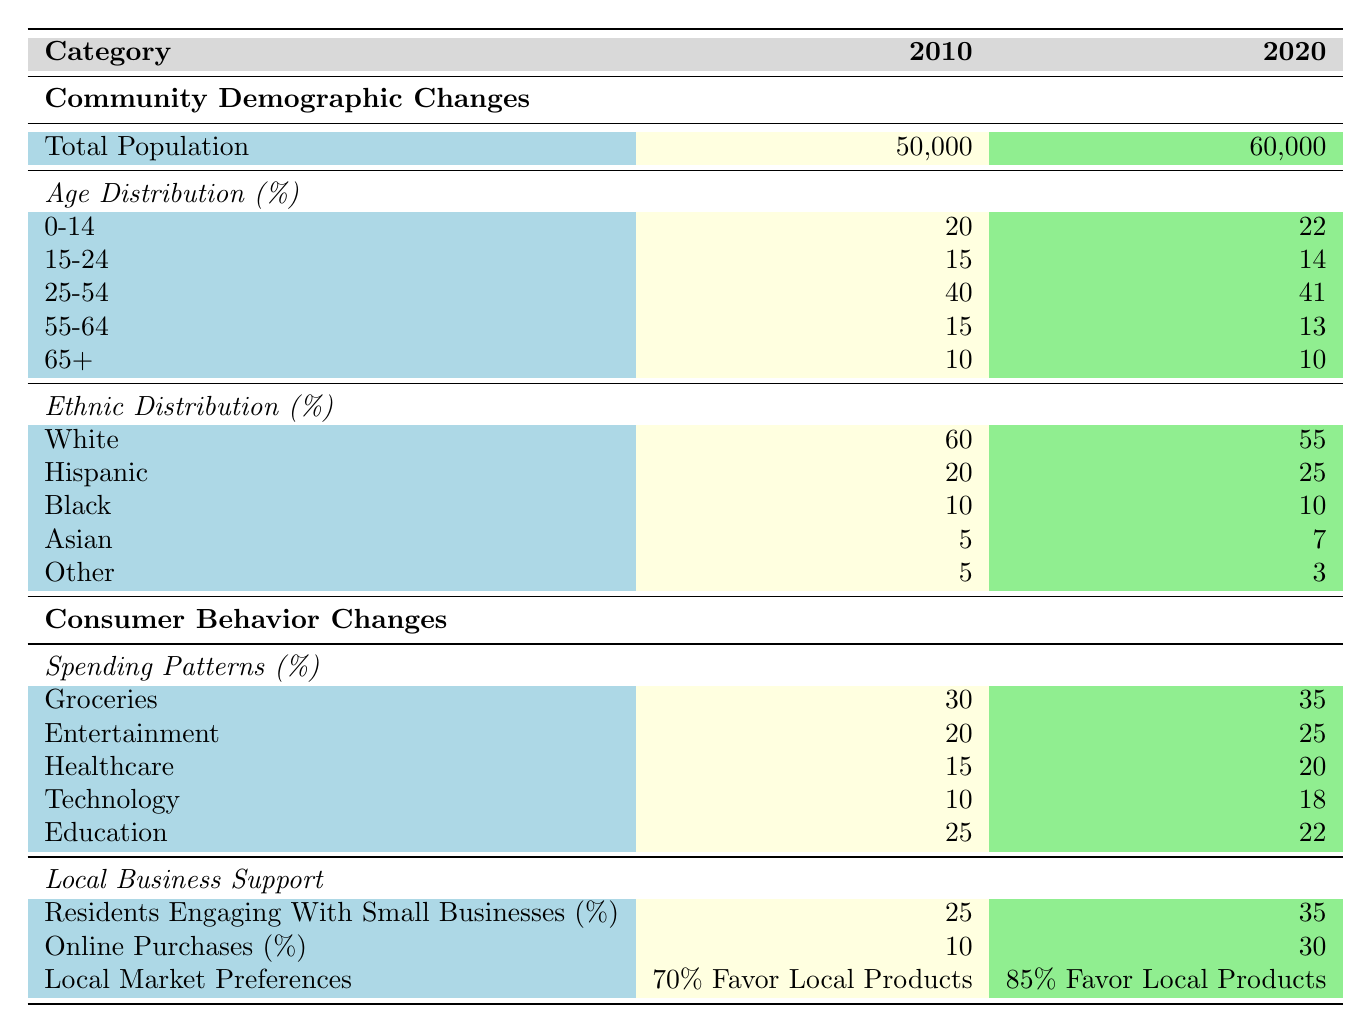What was the total population in 2010? Referring to the table, in the Community Demographic Changes section, the Total Population for the year 2010 is listed as 50,000.
Answer: 50,000 What percentage of the population in 2020 was aged 25-54? Checking the Age Distribution section for the year 2020, the percentage of the population aged 25-54 is noted as 41%.
Answer: 41% Did the percentage of residents engaging with small businesses increase from 2010 to 2020? By examining the Local Business Support section, the percentage in 2010 was 25%, and in 2020 it increased to 35%. Hence, it indeed increased.
Answer: Yes What is the total percentage increase in spending on Technology from 2010 to 2020? The spending on Technology in 2010 was 10%, and in 2020 it rose to 18%. To calculate the increase: 18 - 10 = 8%. Therefore, the total percentage increase is 8%.
Answer: 8% Was the percentage of online purchases higher in 2020 than in 2010? Looking at the Local Business Support section, online purchases were 10% in 2010 and increased to 30% in 2020. This shows the percentage was higher in 2020.
Answer: Yes What was the combined percentage of the population aged 0-14 and 15-24 in 2020? Referring to the Age Distribution section for 2020: the percentage aged 0-14 is 22% and 15-24 is 14%. Therefore, the combined percentage is 22 + 14 = 36%.
Answer: 36% How much did the percentage of the Hispanic population change from 2010 to 2020? In 2010, the Hispanic population percentage was 20%, and in 2020 it rose to 25%. The change can be calculated as 25 - 20 = 5%.
Answer: 5% What percentage of residents favored local products in 2010 compared to 2020? According to the Local Market Preferences data, 70% favored local products in 2010, while in 2020 it increased to 85%. Thus, the percentage favored local products was higher in 2020.
Answer: Yes What was the percentage decrease in spending on Education from 2010 to 2020? The spending on Education decreased from 25% in 2010 to 22% in 2020. The decrease is calculated as 25 - 22 = 3%. Thus, the percentage decrease is 3%.
Answer: 3% 